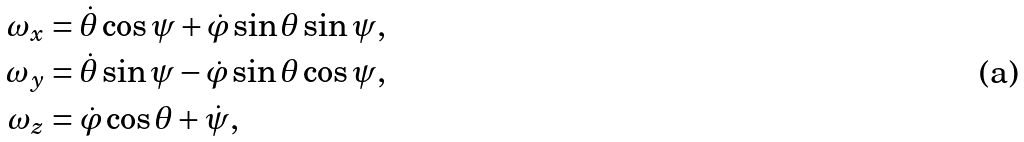<formula> <loc_0><loc_0><loc_500><loc_500>\omega _ { x } & = \dot { \theta } \cos \psi + \dot { \varphi } \sin \theta \sin \psi , \\ \omega _ { y } & = \dot { \theta } \sin \psi - \dot { \varphi } \sin \theta \cos \psi , \\ \omega _ { z } & = \dot { \varphi } \cos \theta + \dot { \psi } ,</formula> 